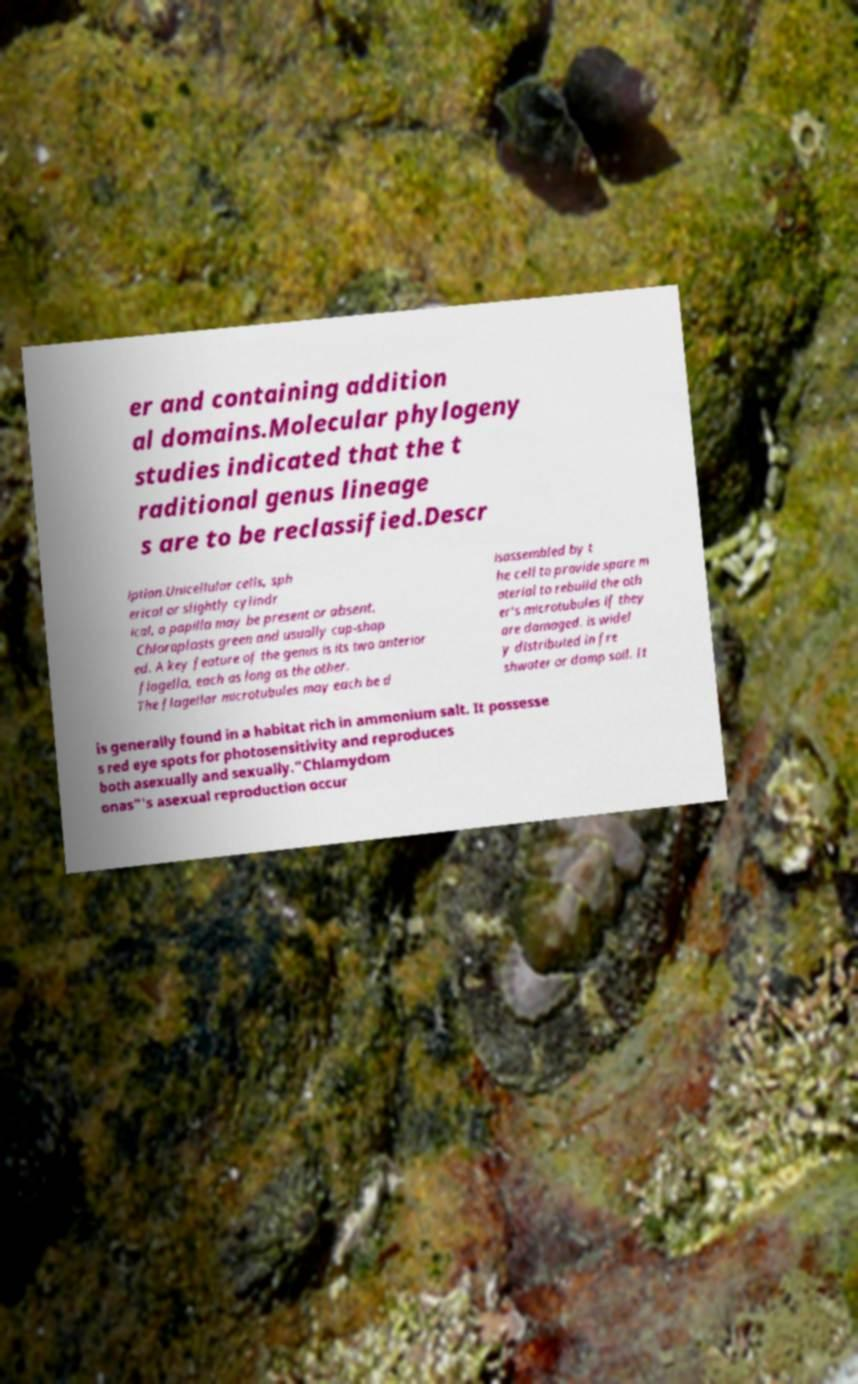For documentation purposes, I need the text within this image transcribed. Could you provide that? er and containing addition al domains.Molecular phylogeny studies indicated that the t raditional genus lineage s are to be reclassified.Descr iption.Unicellular cells, sph erical or slightly cylindr ical, a papilla may be present or absent. Chloroplasts green and usually cup-shap ed. A key feature of the genus is its two anterior flagella, each as long as the other. The flagellar microtubules may each be d isassembled by t he cell to provide spare m aterial to rebuild the oth er's microtubules if they are damaged. is widel y distributed in fre shwater or damp soil. It is generally found in a habitat rich in ammonium salt. It possesse s red eye spots for photosensitivity and reproduces both asexually and sexually."Chlamydom onas"'s asexual reproduction occur 